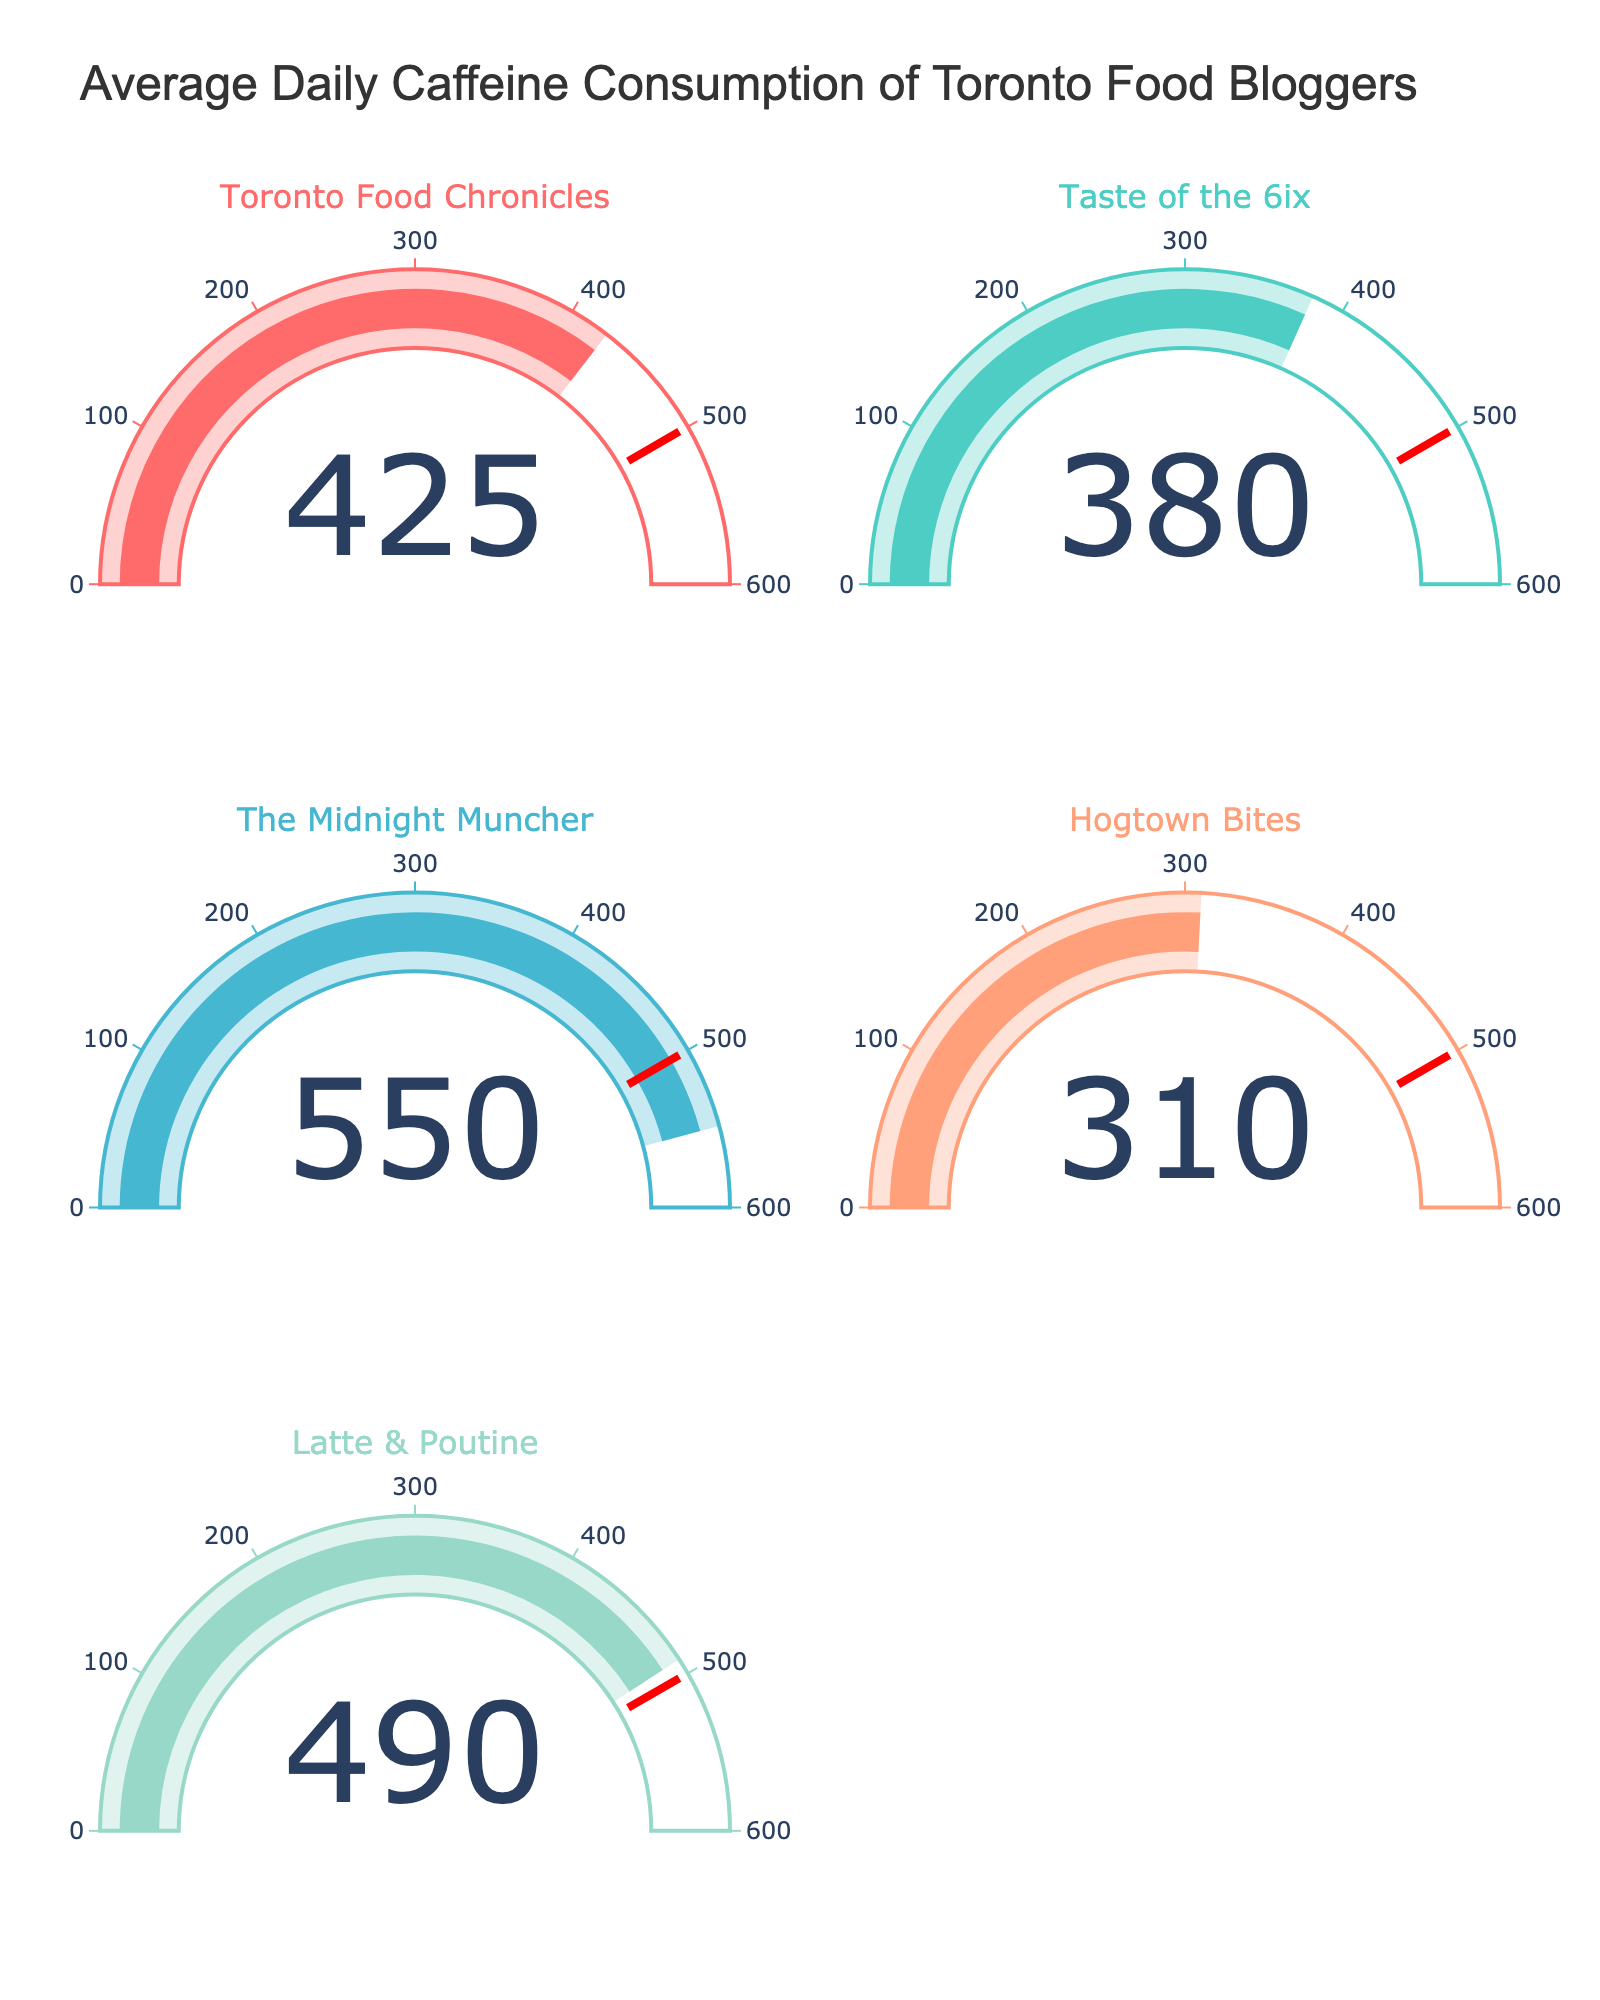What's the average daily caffeine consumption of 'The Midnight Muncher'? Look at the gauge chart for 'The Midnight Muncher' and note the displayed number, which is 550 milligrams.
Answer: 550 milligrams Which food blogger has the lowest average daily caffeine consumption? Examine each gauge chart and compare the values. 'Hogtown Bites' has the lowest value at 310 milligrams.
Answer: Hogtown Bites What's the difference in caffeine consumption between 'Latte & Poutine' and 'Taste of the 6ix'? Locate the values for both 'Latte & Poutine' (490 milligrams) and 'Taste of the 6ix' (380 milligrams). Subtract 380 from 490 to get the difference.
Answer: 110 milligrams How many food bloggers have an average daily caffeine consumption above 400 milligrams? Count the number of gauges with values greater than 400. 'Toronto Food Chronicles', 'The Midnight Muncher', and 'Latte & Poutine' all have values above 400.
Answer: 3 What's the sum of the average daily caffeine consumption for all the food bloggers? Add the values from all gauge charts: 425 (Toronto Food Chronicles), 380 (Taste of the 6ix), 550 (The Midnight Muncher), 310 (Hogtown Bites), and 490 (Latte & Poutine). The total is 425 + 380 + 550 + 310 + 490 = 2155 milligrams.
Answer: 2155 milligrams Is the average daily caffeine consumption of 'Toronto Food Chronicles' greater than that of 'Hogtown Bites'? Compare the values displayed on the gauge charts for 'Toronto Food Chronicles' (425 milligrams) and 'Hogtown Bites' (310 milligrams).
Answer: Yes Which food blogger's caffeine consumption is closest to the threshold value of 500 milligrams? Compare each value to 500 milligrams and see which is closest. 'Latte & Poutine' has a value of 490 milligrams, which is closest to the threshold.
Answer: Latte & Poutine Do any food bloggers exceed the 500 milligram threshold? If so, who? Look for any gauge charts with values over 500 milligrams. 'The Midnight Muncher' has 550 milligrams, which exceeds the threshold.
Answer: The Midnight Muncher What's the range of average daily caffeine consumption among these food bloggers? Determine the minimum and maximum values. The minimum is 310 milligrams ('Hogtown Bites') and the maximum is 550 milligrams ('The Midnight Muncher'). The range is 550 - 310 = 240 milligrams.
Answer: 240 milligrams 